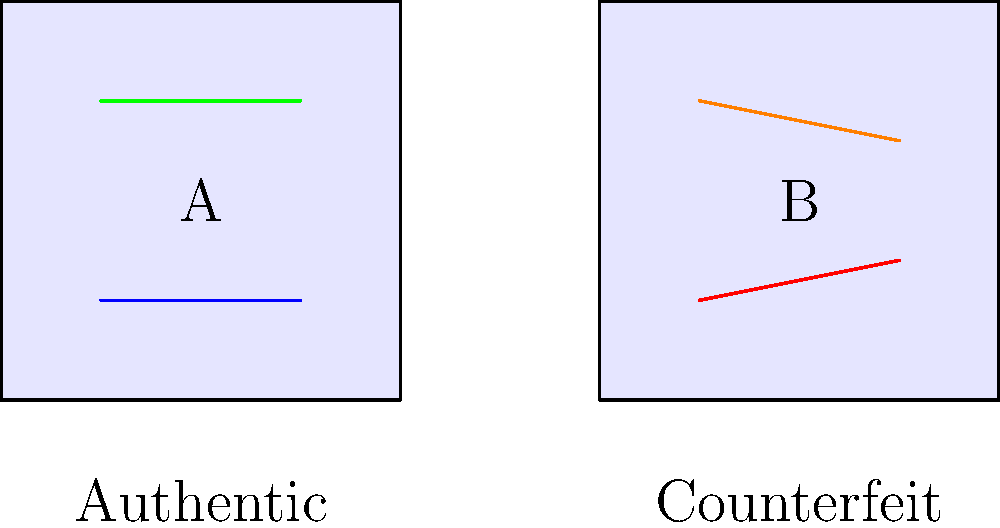Examine the two Japanese import items shown above. Which subtle difference indicates that item B is likely a counterfeit? To identify the subtle difference indicating that item B is likely a counterfeit, let's analyze the visual cues step-by-step:

1. Both items A and B have similar overall shapes, representing Japanese import items.

2. Item A (Authentic):
   - Has two horizontal lines: one blue (bottom) and one green (top).
   - Both lines are perfectly straight and parallel to the bottom edge.

3. Item B (Counterfeit):
   - Also has two horizontal lines: one red (bottom) and one orange (top).
   - The bottom red line is slightly angled upwards on the right side.
   - The top orange line is slightly angled downwards on the right side.

4. The key difference:
   - In authentic Japanese import items, precise craftsmanship is crucial.
   - The slight angles in the lines of item B indicate lower precision in manufacturing.

5. Conclusion:
   - The angled lines in item B, particularly the bottom red line, are the subtle difference that suggests it is likely a counterfeit.
Answer: Angled bottom line 